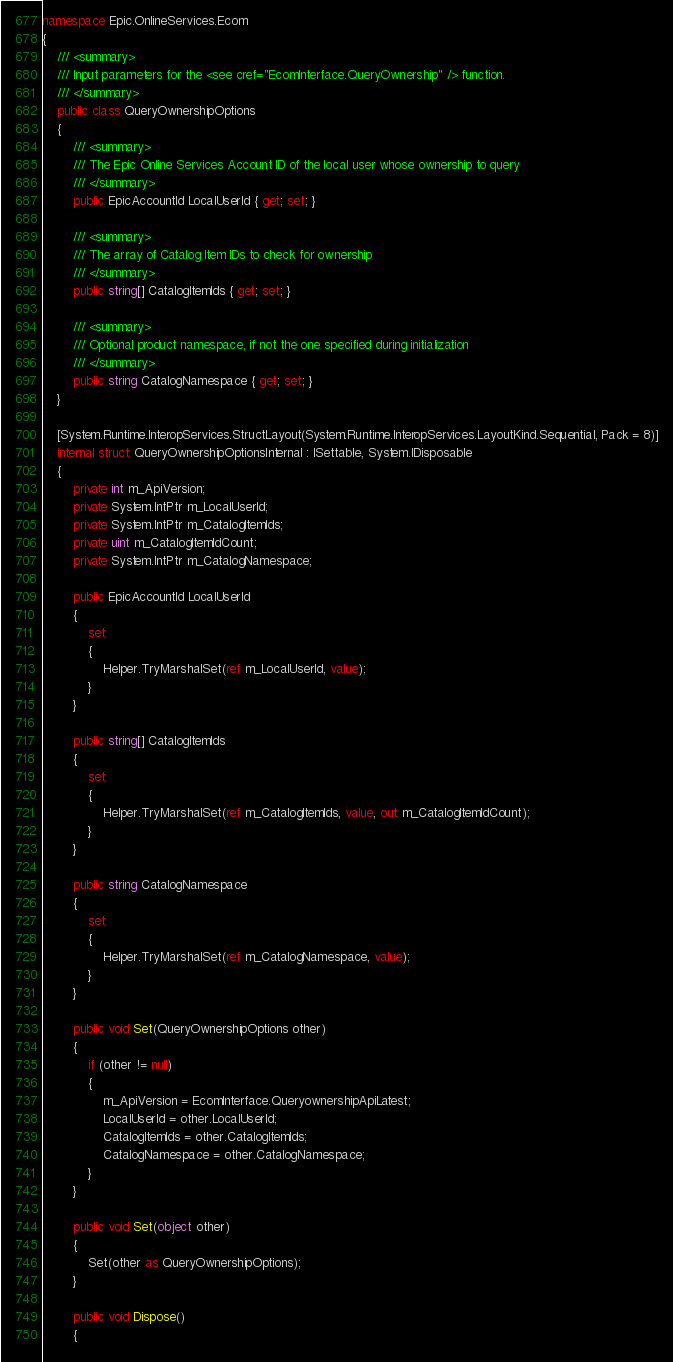Convert code to text. <code><loc_0><loc_0><loc_500><loc_500><_C#_>namespace Epic.OnlineServices.Ecom
{
	/// <summary>
	/// Input parameters for the <see cref="EcomInterface.QueryOwnership" /> function.
	/// </summary>
	public class QueryOwnershipOptions
	{
		/// <summary>
		/// The Epic Online Services Account ID of the local user whose ownership to query
		/// </summary>
		public EpicAccountId LocalUserId { get; set; }

		/// <summary>
		/// The array of Catalog Item IDs to check for ownership
		/// </summary>
		public string[] CatalogItemIds { get; set; }

		/// <summary>
		/// Optional product namespace, if not the one specified during initialization
		/// </summary>
		public string CatalogNamespace { get; set; }
	}

	[System.Runtime.InteropServices.StructLayout(System.Runtime.InteropServices.LayoutKind.Sequential, Pack = 8)]
	internal struct QueryOwnershipOptionsInternal : ISettable, System.IDisposable
	{
		private int m_ApiVersion;
		private System.IntPtr m_LocalUserId;
		private System.IntPtr m_CatalogItemIds;
		private uint m_CatalogItemIdCount;
		private System.IntPtr m_CatalogNamespace;

		public EpicAccountId LocalUserId
		{
			set
			{
				Helper.TryMarshalSet(ref m_LocalUserId, value);
			}
		}

		public string[] CatalogItemIds
		{
			set
			{
				Helper.TryMarshalSet(ref m_CatalogItemIds, value, out m_CatalogItemIdCount);
			}
		}

		public string CatalogNamespace
		{
			set
			{
				Helper.TryMarshalSet(ref m_CatalogNamespace, value);
			}
		}

		public void Set(QueryOwnershipOptions other)
		{
			if (other != null)
			{
				m_ApiVersion = EcomInterface.QueryownershipApiLatest;
				LocalUserId = other.LocalUserId;
				CatalogItemIds = other.CatalogItemIds;
				CatalogNamespace = other.CatalogNamespace;
			}
		}

		public void Set(object other)
		{
			Set(other as QueryOwnershipOptions);
		}

		public void Dispose()
		{</code> 